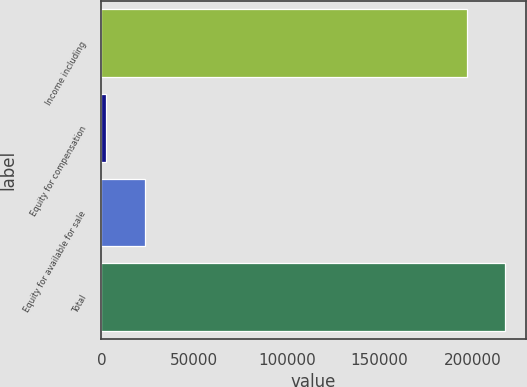Convert chart. <chart><loc_0><loc_0><loc_500><loc_500><bar_chart><fcel>Income including<fcel>Equity for compensation<fcel>Equity for available for sale<fcel>Total<nl><fcel>197033<fcel>2590<fcel>23360<fcel>217803<nl></chart> 